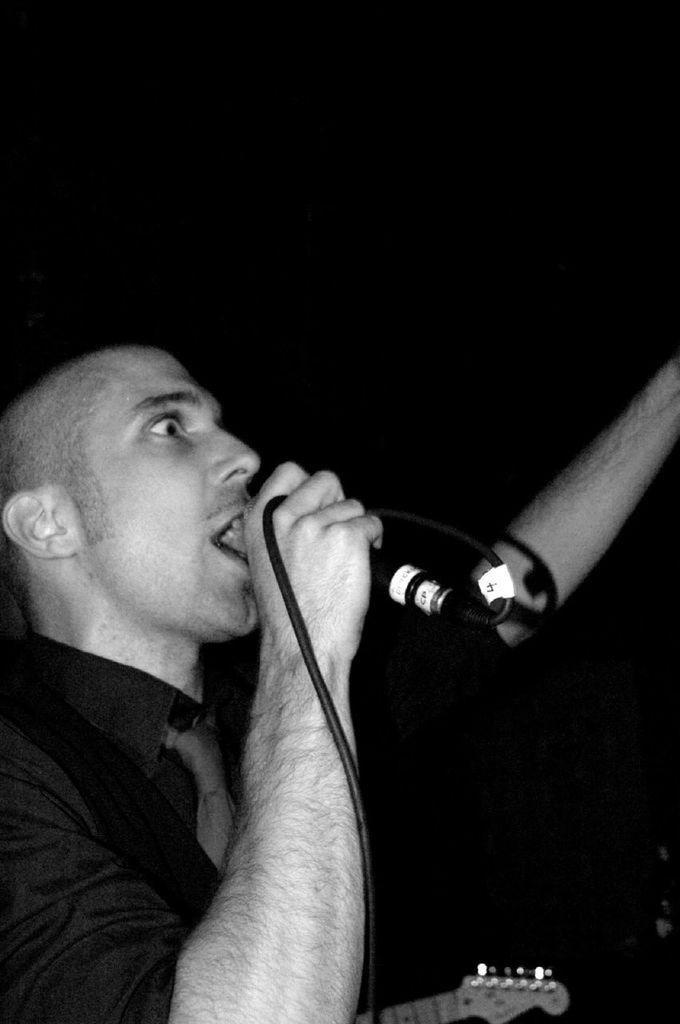Who is the main subject in the image? There is a boy in the image. Where is the boy positioned in the image? The boy is standing at the left side of the image. What objects is the boy holding in his hands? The boy is holding a mic and a guitar in his hands. What is the color of the background in the image? The background color of the image is black. What type of tin can be seen in the image? There is no tin present in the image. What is the angle of the guitar in the image? The image does not provide enough information to determine the angle of the guitar. 